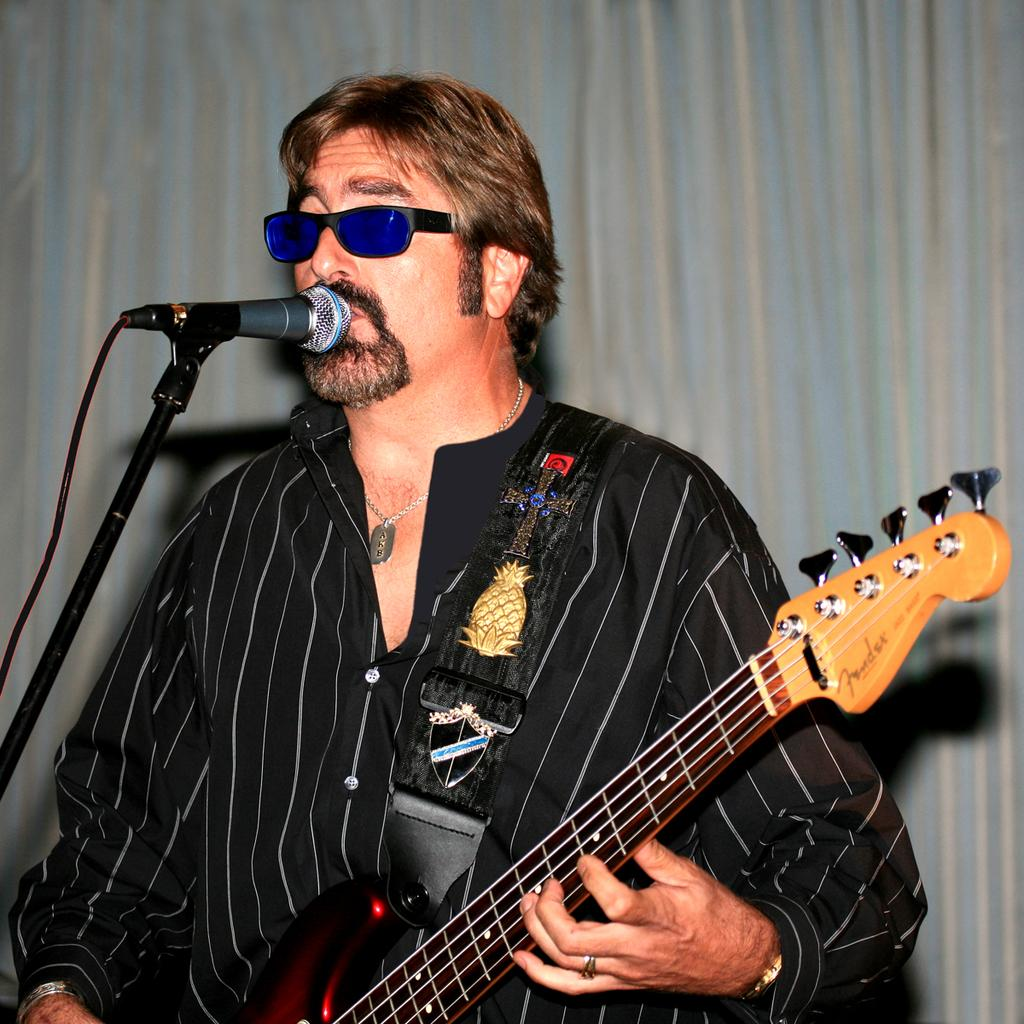What is the main subject of the image? The main subject of the image is a man. What is the man wearing in the image? The man is wearing goggles in the image. What is the man doing in front of the microphone? The man is playing a guitar in front of the microphone. What type of collar can be seen on the man's pet in the image? There is no pet present in the image, so there is no collar to be seen. How much payment is the man receiving for his performance in the image? The image does not provide any information about payment, so it cannot be determined. 